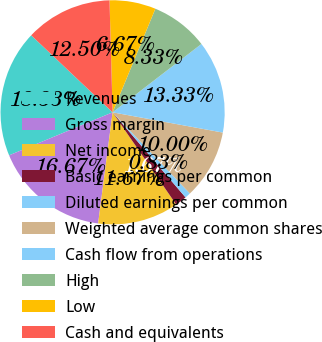Convert chart to OTSL. <chart><loc_0><loc_0><loc_500><loc_500><pie_chart><fcel>Revenues<fcel>Gross margin<fcel>Net income<fcel>Basic earnings per common<fcel>Diluted earnings per common<fcel>Weighted average common shares<fcel>Cash flow from operations<fcel>High<fcel>Low<fcel>Cash and equivalents<nl><fcel>18.33%<fcel>16.67%<fcel>11.67%<fcel>1.67%<fcel>0.83%<fcel>10.0%<fcel>13.33%<fcel>8.33%<fcel>6.67%<fcel>12.5%<nl></chart> 